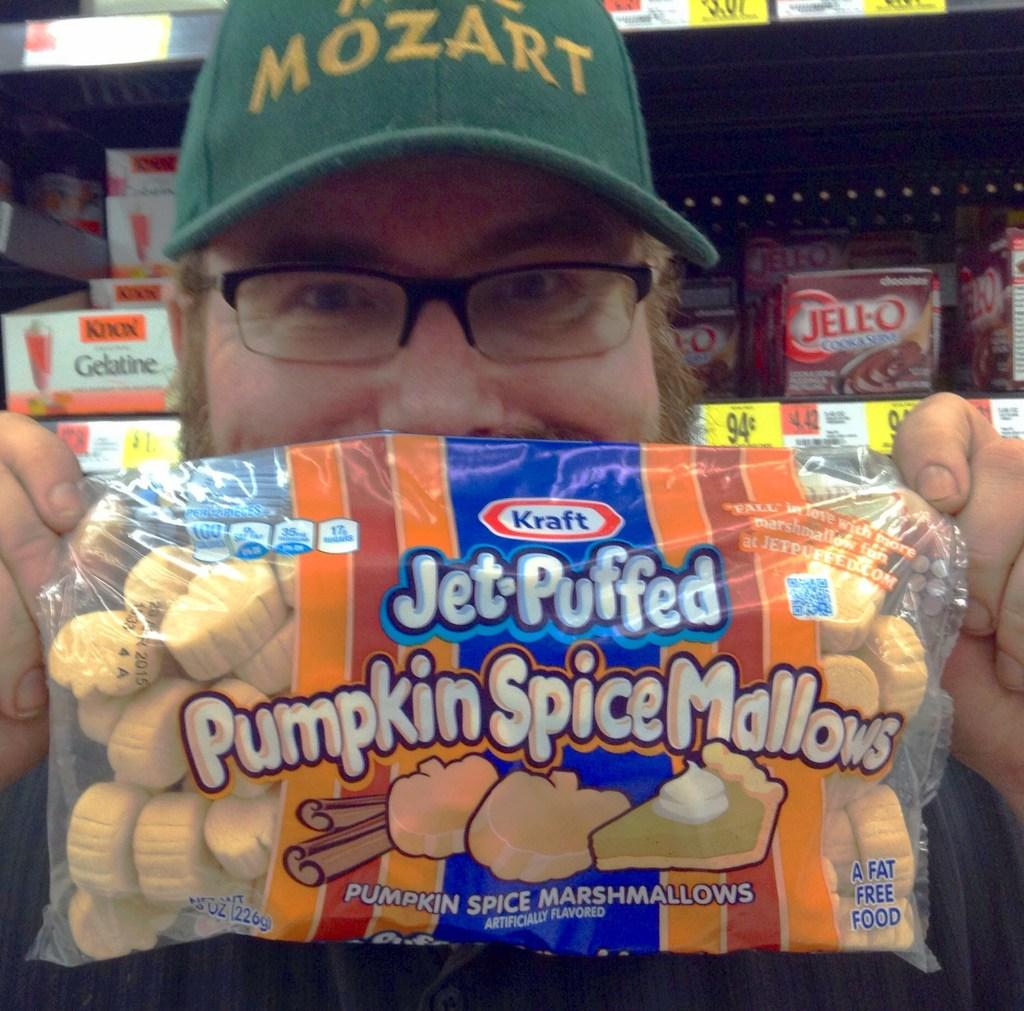Who is present in the image? There is a man in the image. What is the man holding in the image? The man is holding a packet. What accessories is the man wearing in the image? The man is wearing a hat and specs. What can be seen in the background of the image? There are products displayed on a rack in the background of the image. What type of scissors is the man using to cut the packet in the image? There are no scissors present in the image, and the man is not cutting the packet. What trade is the man involved in, as depicted in the image? The image does not provide any information about the man's trade or profession. 